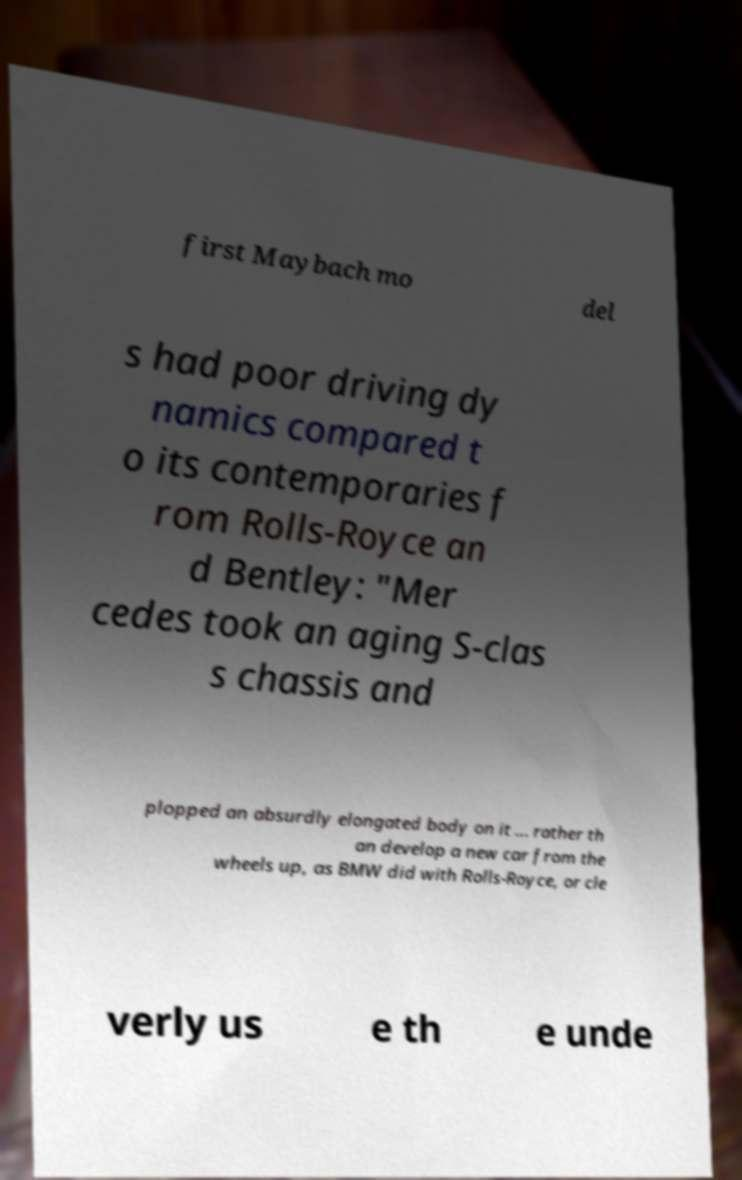Please read and relay the text visible in this image. What does it say? first Maybach mo del s had poor driving dy namics compared t o its contemporaries f rom Rolls-Royce an d Bentley: "Mer cedes took an aging S-clas s chassis and plopped an absurdly elongated body on it ... rather th an develop a new car from the wheels up, as BMW did with Rolls-Royce, or cle verly us e th e unde 